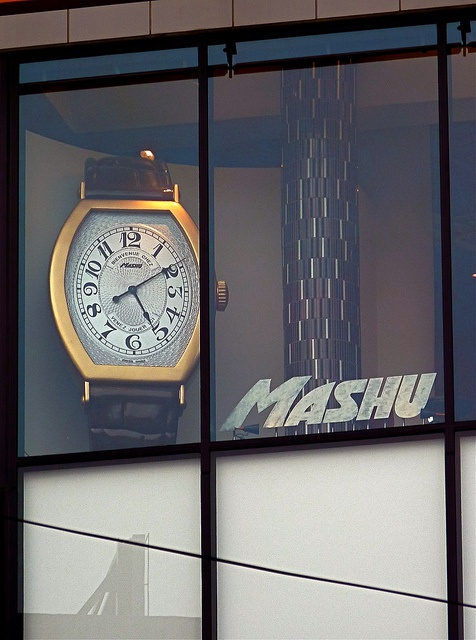Describe the objects in this image and their specific colors. I can see a clock in brown, darkgray, lightgray, gray, and tan tones in this image. 